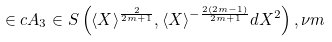Convert formula to latex. <formula><loc_0><loc_0><loc_500><loc_500>\in c A _ { 3 } \in S \left ( \langle X \rangle ^ { \frac { 2 } { 2 m + 1 } } , \langle X \rangle ^ { - \frac { 2 ( 2 m - 1 ) } { 2 m + 1 } } d X ^ { 2 } \right ) , \nu m</formula> 